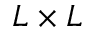<formula> <loc_0><loc_0><loc_500><loc_500>L \times L</formula> 